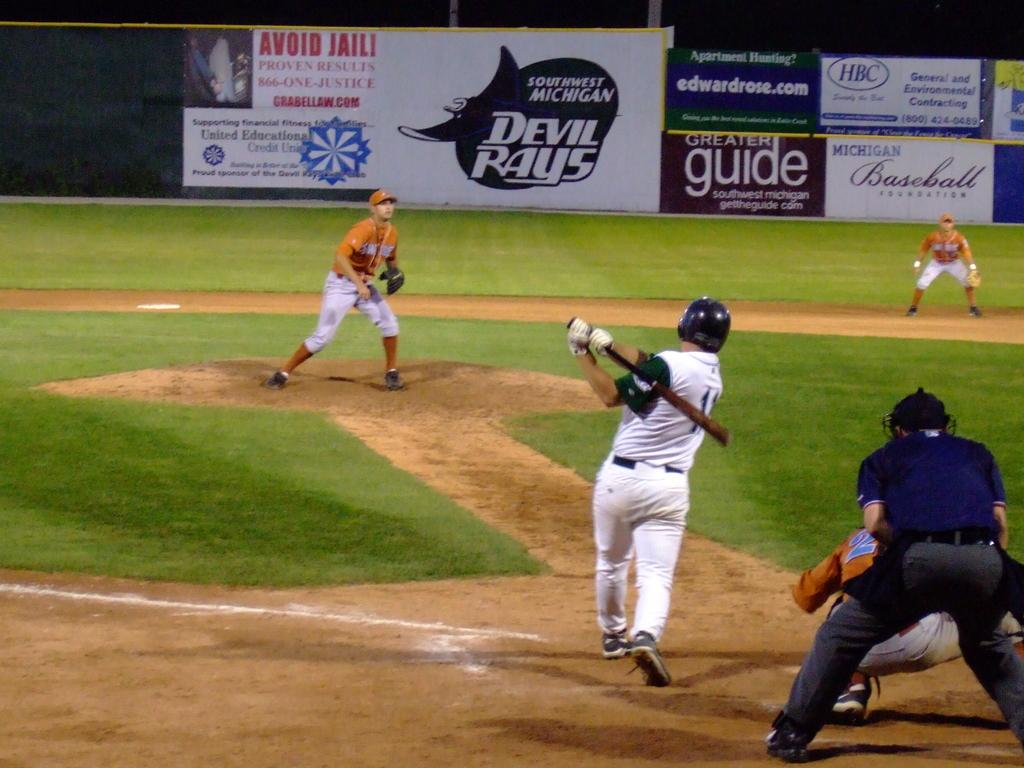<image>
Render a clear and concise summary of the photo. A baseball player hits the ball towards signs that say Devil Rays, Greater Guide, and more. 